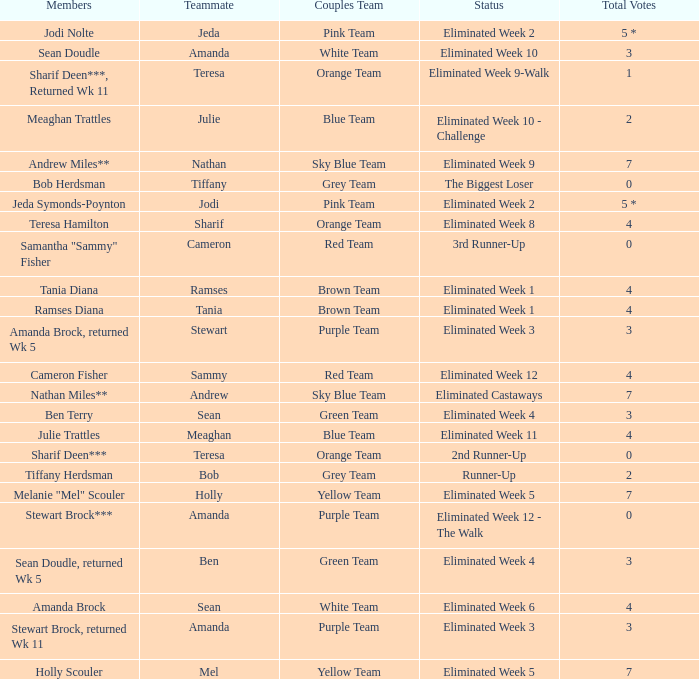What was the total number of votes holly scouler received? 7.0. 